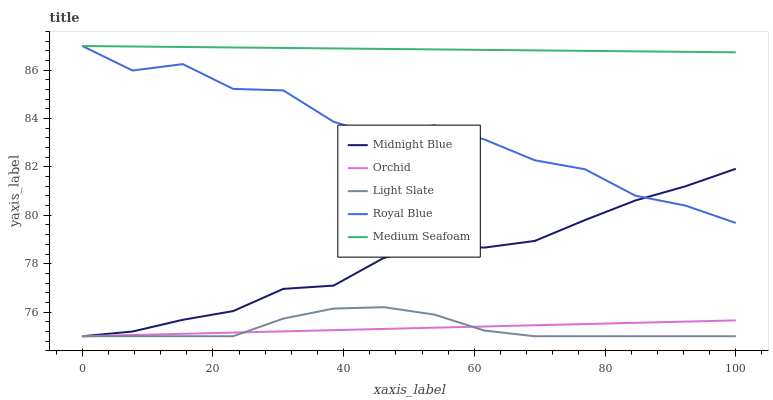Does Light Slate have the minimum area under the curve?
Answer yes or no. Yes. Does Medium Seafoam have the maximum area under the curve?
Answer yes or no. Yes. Does Royal Blue have the minimum area under the curve?
Answer yes or no. No. Does Royal Blue have the maximum area under the curve?
Answer yes or no. No. Is Medium Seafoam the smoothest?
Answer yes or no. Yes. Is Royal Blue the roughest?
Answer yes or no. Yes. Is Royal Blue the smoothest?
Answer yes or no. No. Is Medium Seafoam the roughest?
Answer yes or no. No. Does Light Slate have the lowest value?
Answer yes or no. Yes. Does Royal Blue have the lowest value?
Answer yes or no. No. Does Medium Seafoam have the highest value?
Answer yes or no. Yes. Does Midnight Blue have the highest value?
Answer yes or no. No. Is Light Slate less than Royal Blue?
Answer yes or no. Yes. Is Royal Blue greater than Orchid?
Answer yes or no. Yes. Does Midnight Blue intersect Royal Blue?
Answer yes or no. Yes. Is Midnight Blue less than Royal Blue?
Answer yes or no. No. Is Midnight Blue greater than Royal Blue?
Answer yes or no. No. Does Light Slate intersect Royal Blue?
Answer yes or no. No. 